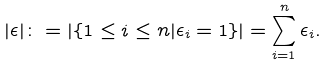<formula> <loc_0><loc_0><loc_500><loc_500>| \epsilon | \colon = | \{ 1 \leq i \leq n | \epsilon _ { i } = 1 \} | = \sum _ { i = 1 } ^ { n } \epsilon _ { i } .</formula> 